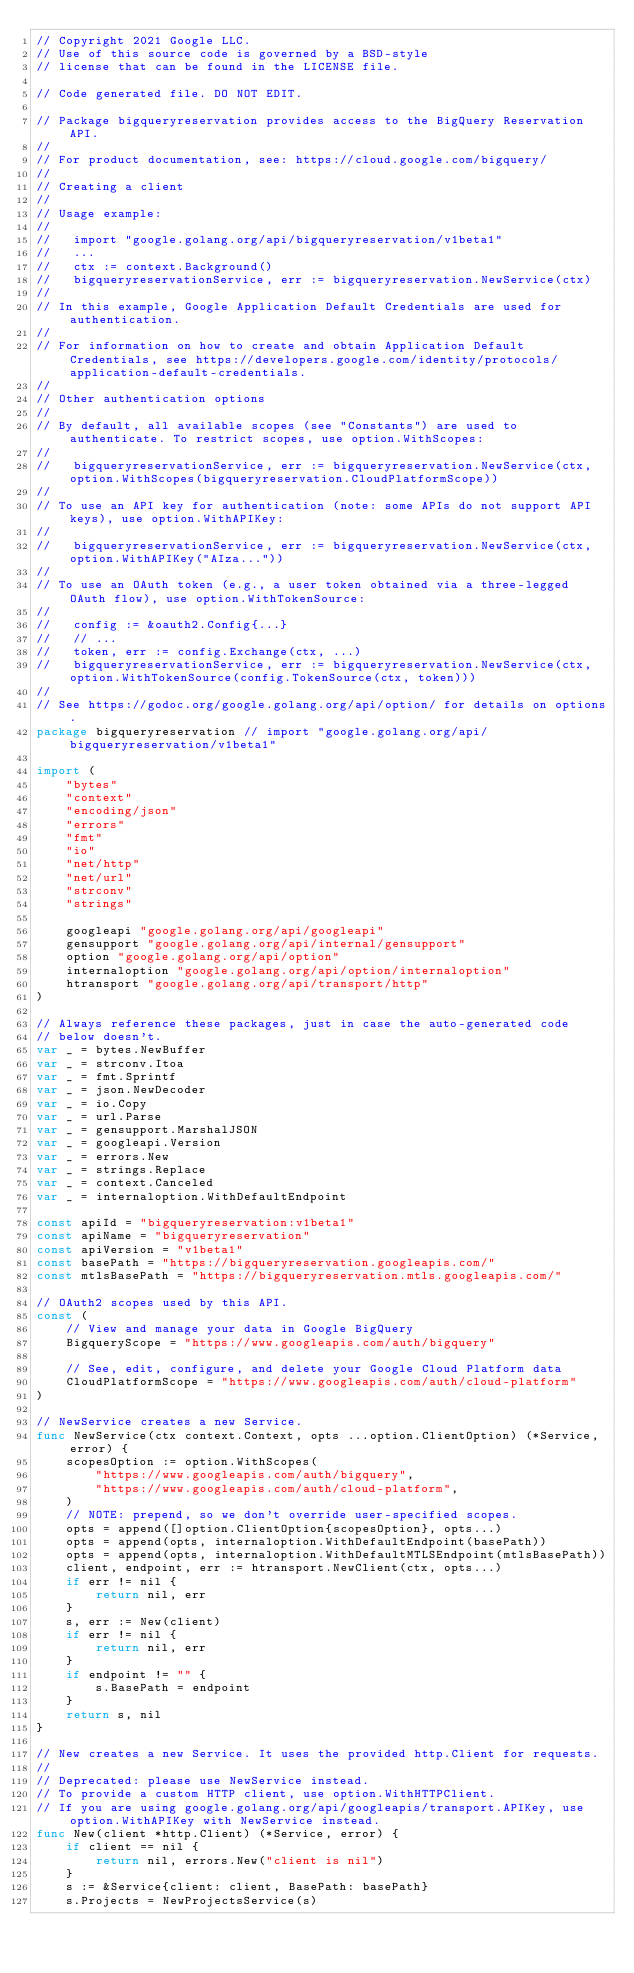<code> <loc_0><loc_0><loc_500><loc_500><_Go_>// Copyright 2021 Google LLC.
// Use of this source code is governed by a BSD-style
// license that can be found in the LICENSE file.

// Code generated file. DO NOT EDIT.

// Package bigqueryreservation provides access to the BigQuery Reservation API.
//
// For product documentation, see: https://cloud.google.com/bigquery/
//
// Creating a client
//
// Usage example:
//
//   import "google.golang.org/api/bigqueryreservation/v1beta1"
//   ...
//   ctx := context.Background()
//   bigqueryreservationService, err := bigqueryreservation.NewService(ctx)
//
// In this example, Google Application Default Credentials are used for authentication.
//
// For information on how to create and obtain Application Default Credentials, see https://developers.google.com/identity/protocols/application-default-credentials.
//
// Other authentication options
//
// By default, all available scopes (see "Constants") are used to authenticate. To restrict scopes, use option.WithScopes:
//
//   bigqueryreservationService, err := bigqueryreservation.NewService(ctx, option.WithScopes(bigqueryreservation.CloudPlatformScope))
//
// To use an API key for authentication (note: some APIs do not support API keys), use option.WithAPIKey:
//
//   bigqueryreservationService, err := bigqueryreservation.NewService(ctx, option.WithAPIKey("AIza..."))
//
// To use an OAuth token (e.g., a user token obtained via a three-legged OAuth flow), use option.WithTokenSource:
//
//   config := &oauth2.Config{...}
//   // ...
//   token, err := config.Exchange(ctx, ...)
//   bigqueryreservationService, err := bigqueryreservation.NewService(ctx, option.WithTokenSource(config.TokenSource(ctx, token)))
//
// See https://godoc.org/google.golang.org/api/option/ for details on options.
package bigqueryreservation // import "google.golang.org/api/bigqueryreservation/v1beta1"

import (
	"bytes"
	"context"
	"encoding/json"
	"errors"
	"fmt"
	"io"
	"net/http"
	"net/url"
	"strconv"
	"strings"

	googleapi "google.golang.org/api/googleapi"
	gensupport "google.golang.org/api/internal/gensupport"
	option "google.golang.org/api/option"
	internaloption "google.golang.org/api/option/internaloption"
	htransport "google.golang.org/api/transport/http"
)

// Always reference these packages, just in case the auto-generated code
// below doesn't.
var _ = bytes.NewBuffer
var _ = strconv.Itoa
var _ = fmt.Sprintf
var _ = json.NewDecoder
var _ = io.Copy
var _ = url.Parse
var _ = gensupport.MarshalJSON
var _ = googleapi.Version
var _ = errors.New
var _ = strings.Replace
var _ = context.Canceled
var _ = internaloption.WithDefaultEndpoint

const apiId = "bigqueryreservation:v1beta1"
const apiName = "bigqueryreservation"
const apiVersion = "v1beta1"
const basePath = "https://bigqueryreservation.googleapis.com/"
const mtlsBasePath = "https://bigqueryreservation.mtls.googleapis.com/"

// OAuth2 scopes used by this API.
const (
	// View and manage your data in Google BigQuery
	BigqueryScope = "https://www.googleapis.com/auth/bigquery"

	// See, edit, configure, and delete your Google Cloud Platform data
	CloudPlatformScope = "https://www.googleapis.com/auth/cloud-platform"
)

// NewService creates a new Service.
func NewService(ctx context.Context, opts ...option.ClientOption) (*Service, error) {
	scopesOption := option.WithScopes(
		"https://www.googleapis.com/auth/bigquery",
		"https://www.googleapis.com/auth/cloud-platform",
	)
	// NOTE: prepend, so we don't override user-specified scopes.
	opts = append([]option.ClientOption{scopesOption}, opts...)
	opts = append(opts, internaloption.WithDefaultEndpoint(basePath))
	opts = append(opts, internaloption.WithDefaultMTLSEndpoint(mtlsBasePath))
	client, endpoint, err := htransport.NewClient(ctx, opts...)
	if err != nil {
		return nil, err
	}
	s, err := New(client)
	if err != nil {
		return nil, err
	}
	if endpoint != "" {
		s.BasePath = endpoint
	}
	return s, nil
}

// New creates a new Service. It uses the provided http.Client for requests.
//
// Deprecated: please use NewService instead.
// To provide a custom HTTP client, use option.WithHTTPClient.
// If you are using google.golang.org/api/googleapis/transport.APIKey, use option.WithAPIKey with NewService instead.
func New(client *http.Client) (*Service, error) {
	if client == nil {
		return nil, errors.New("client is nil")
	}
	s := &Service{client: client, BasePath: basePath}
	s.Projects = NewProjectsService(s)</code> 